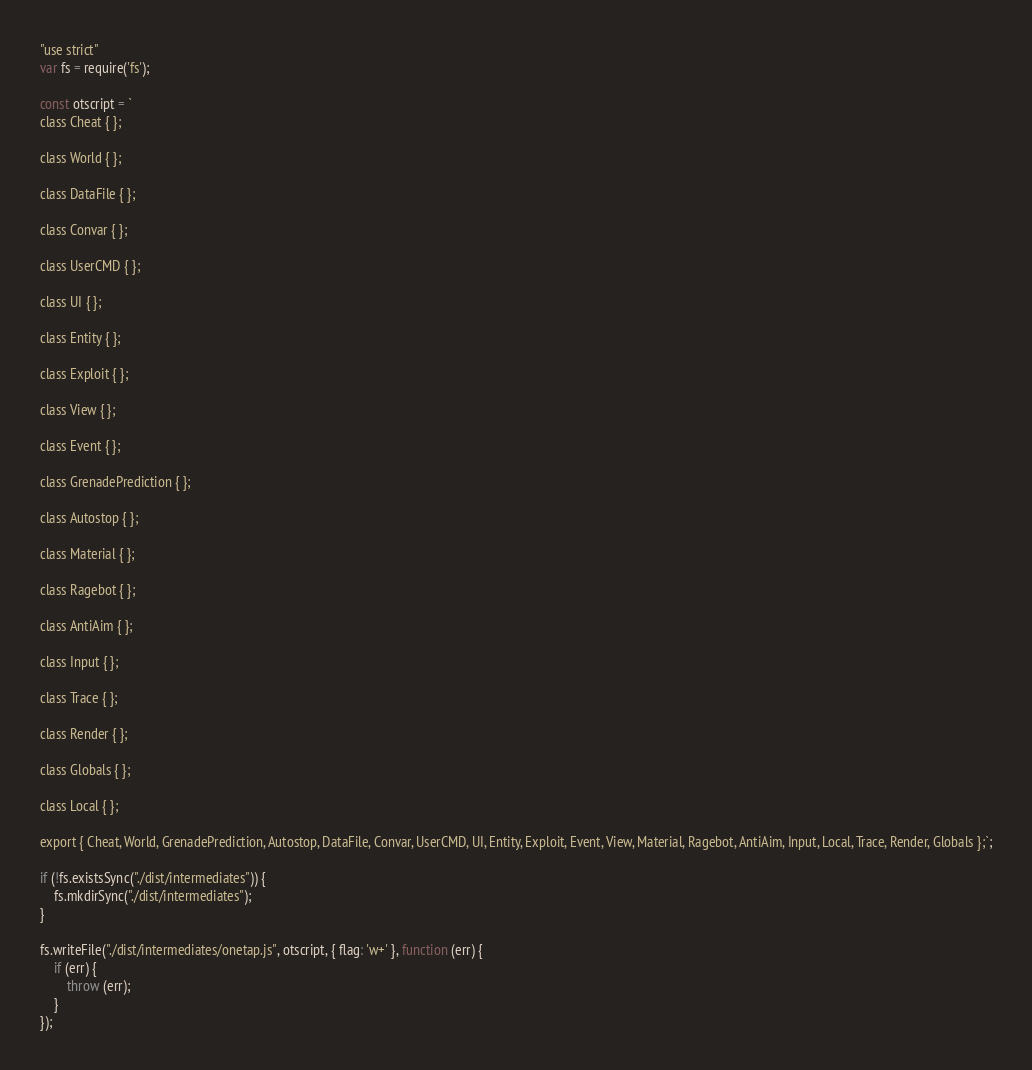Convert code to text. <code><loc_0><loc_0><loc_500><loc_500><_JavaScript_>"use strict"
var fs = require('fs');

const otscript = `
class Cheat { };

class World { };

class DataFile { };

class Convar { };

class UserCMD { };

class UI { };

class Entity { };

class Exploit { };

class View { };

class Event { };

class GrenadePrediction { };

class Autostop { };

class Material { };

class Ragebot { };

class AntiAim { };

class Input { };

class Trace { };

class Render { };

class Globals { };

class Local { };

export { Cheat, World, GrenadePrediction, Autostop, DataFile, Convar, UserCMD, UI, Entity, Exploit, Event, View, Material, Ragebot, AntiAim, Input, Local, Trace, Render, Globals };`;

if (!fs.existsSync("./dist/intermediates")) {
    fs.mkdirSync("./dist/intermediates");
}

fs.writeFile("./dist/intermediates/onetap.js", otscript, { flag: 'w+' }, function (err) {
    if (err) {
        throw (err);
    }
});
</code> 